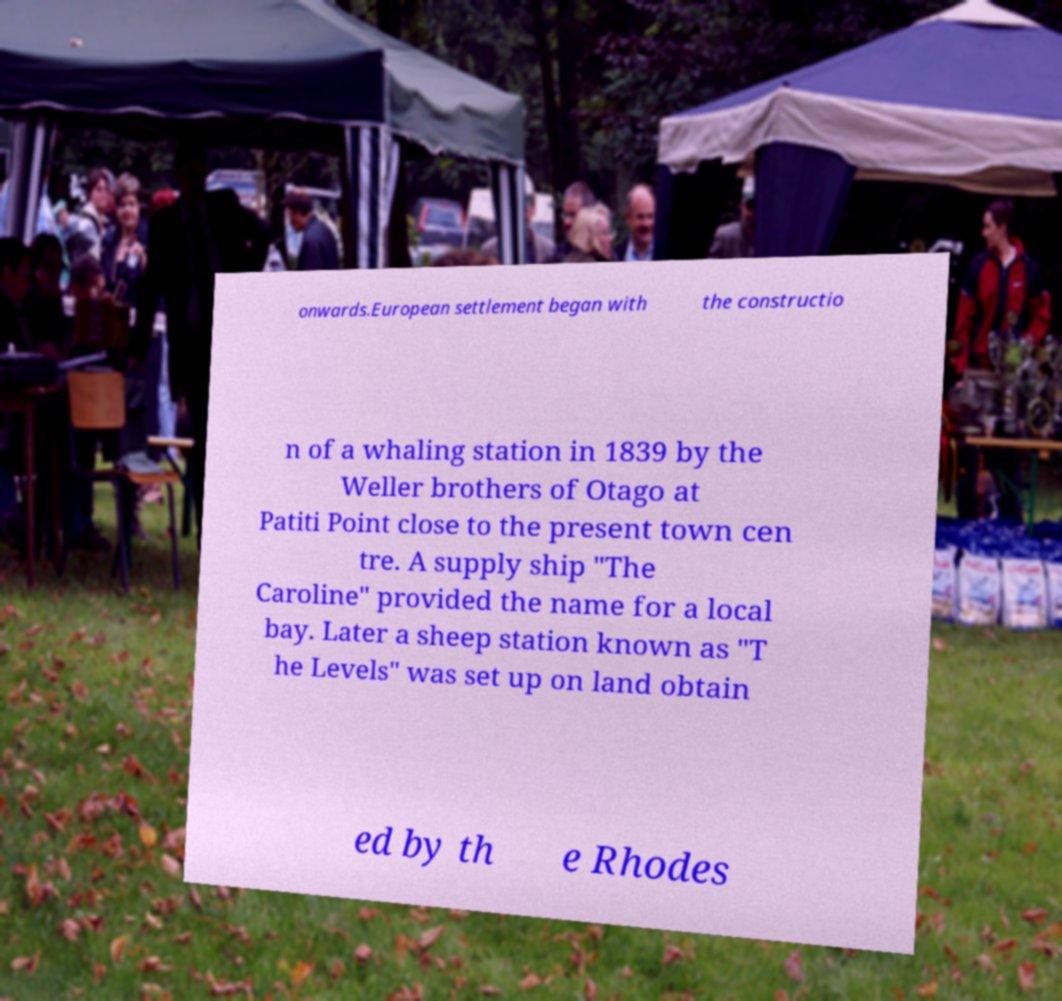Can you accurately transcribe the text from the provided image for me? onwards.European settlement began with the constructio n of a whaling station in 1839 by the Weller brothers of Otago at Patiti Point close to the present town cen tre. A supply ship "The Caroline" provided the name for a local bay. Later a sheep station known as "T he Levels" was set up on land obtain ed by th e Rhodes 